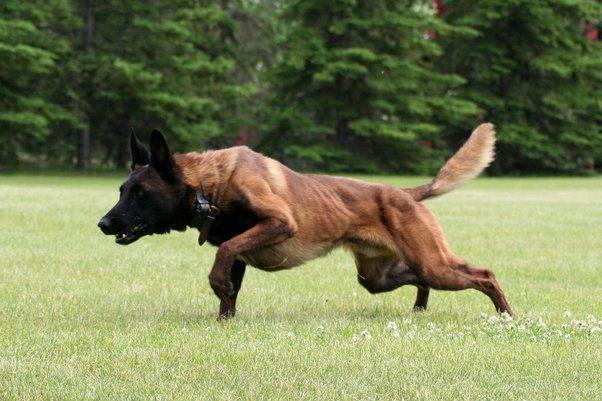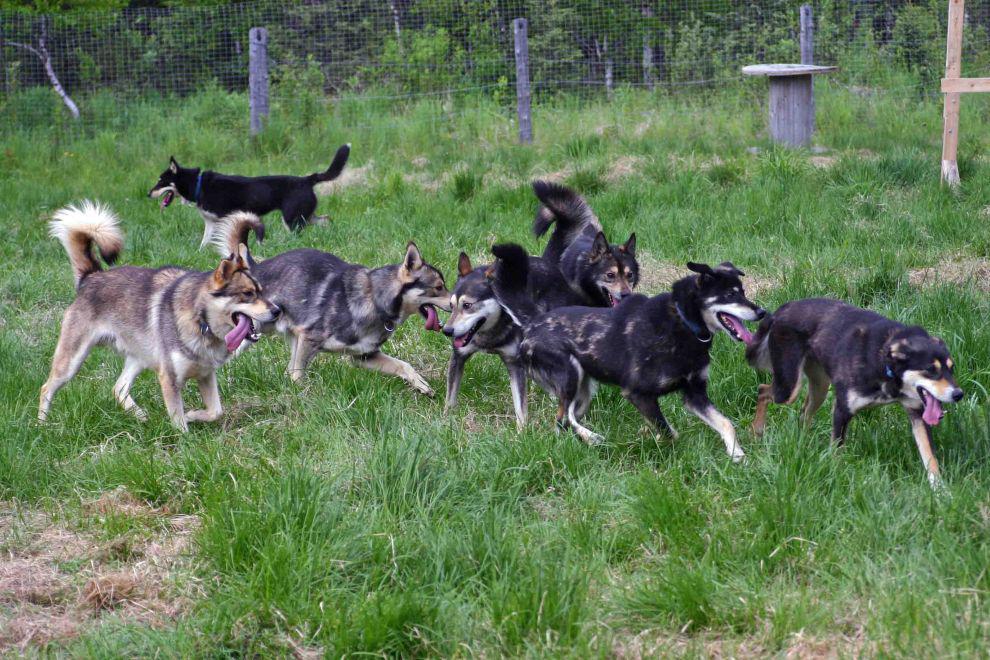The first image is the image on the left, the second image is the image on the right. Assess this claim about the two images: "At least one of the dogs is actively moving by running, jumping, or walking.". Correct or not? Answer yes or no. Yes. 